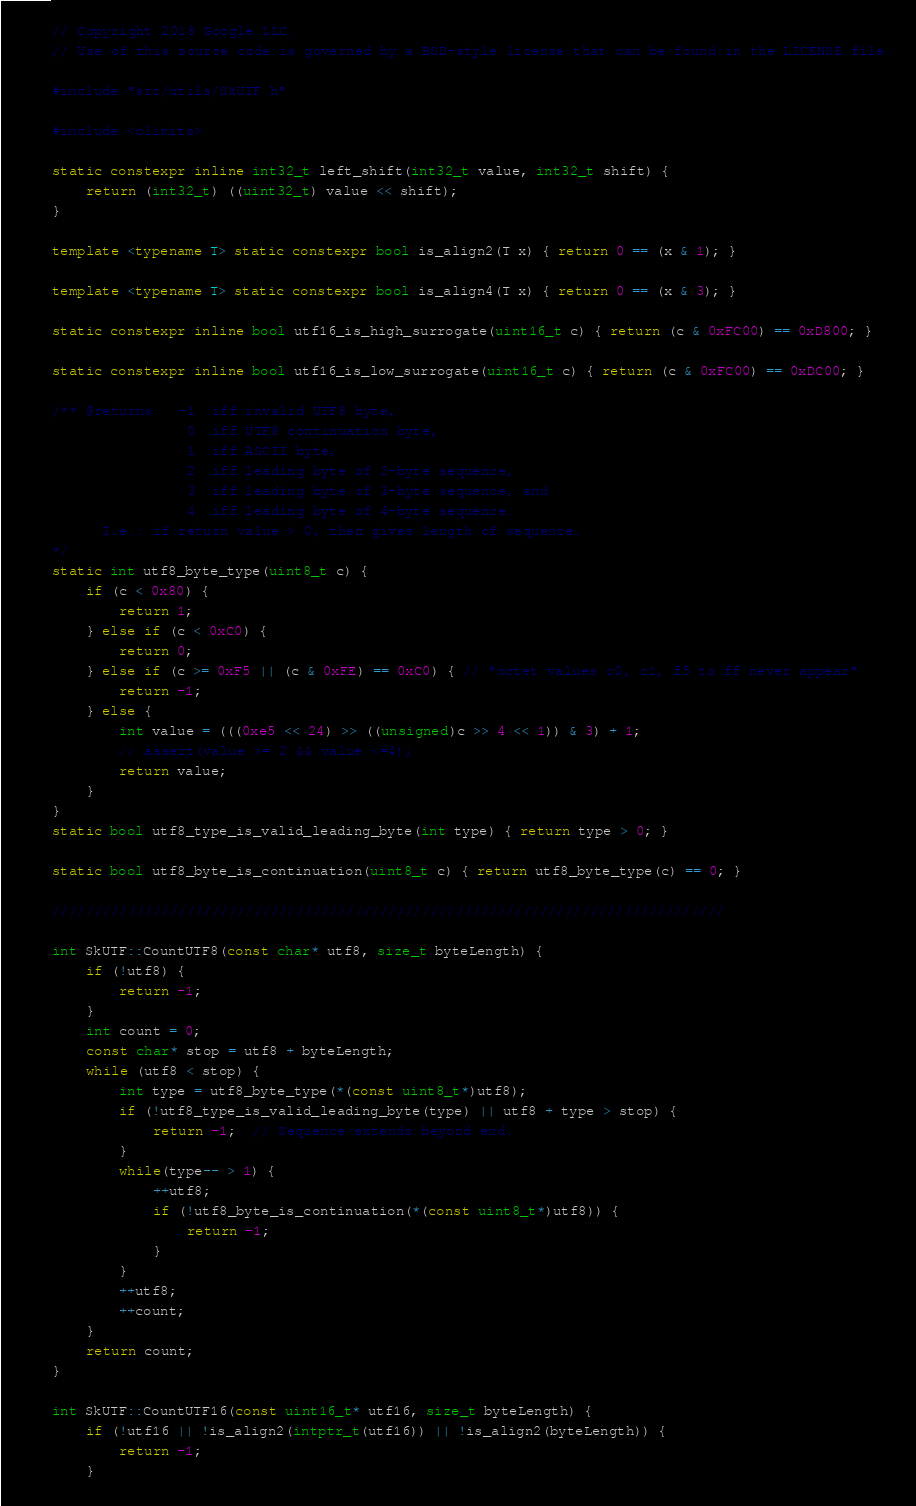<code> <loc_0><loc_0><loc_500><loc_500><_C++_>// Copyright 2018 Google LLC.
// Use of this source code is governed by a BSD-style license that can be found in the LICENSE file.

#include "src/utils/SkUTF.h"

#include <climits>

static constexpr inline int32_t left_shift(int32_t value, int32_t shift) {
    return (int32_t) ((uint32_t) value << shift);
}

template <typename T> static constexpr bool is_align2(T x) { return 0 == (x & 1); }

template <typename T> static constexpr bool is_align4(T x) { return 0 == (x & 3); }

static constexpr inline bool utf16_is_high_surrogate(uint16_t c) { return (c & 0xFC00) == 0xD800; }

static constexpr inline bool utf16_is_low_surrogate(uint16_t c) { return (c & 0xFC00) == 0xDC00; }

/** @returns   -1  iff invalid UTF8 byte,
                0  iff UTF8 continuation byte,
                1  iff ASCII byte,
                2  iff leading byte of 2-byte sequence,
                3  iff leading byte of 3-byte sequence, and
                4  iff leading byte of 4-byte sequence.
      I.e.: if return value > 0, then gives length of sequence.
*/
static int utf8_byte_type(uint8_t c) {
    if (c < 0x80) {
        return 1;
    } else if (c < 0xC0) {
        return 0;
    } else if (c >= 0xF5 || (c & 0xFE) == 0xC0) { // "octet values c0, c1, f5 to ff never appear"
        return -1;
    } else {
        int value = (((0xe5 << 24) >> ((unsigned)c >> 4 << 1)) & 3) + 1;
        // assert(value >= 2 && value <=4);
        return value;
    }
}
static bool utf8_type_is_valid_leading_byte(int type) { return type > 0; }

static bool utf8_byte_is_continuation(uint8_t c) { return utf8_byte_type(c) == 0; }

////////////////////////////////////////////////////////////////////////////////

int SkUTF::CountUTF8(const char* utf8, size_t byteLength) {
    if (!utf8) {
        return -1;
    }
    int count = 0;
    const char* stop = utf8 + byteLength;
    while (utf8 < stop) {
        int type = utf8_byte_type(*(const uint8_t*)utf8);
        if (!utf8_type_is_valid_leading_byte(type) || utf8 + type > stop) {
            return -1;  // Sequence extends beyond end.
        }
        while(type-- > 1) {
            ++utf8;
            if (!utf8_byte_is_continuation(*(const uint8_t*)utf8)) {
                return -1;
            }
        }
        ++utf8;
        ++count;
    }
    return count;
}

int SkUTF::CountUTF16(const uint16_t* utf16, size_t byteLength) {
    if (!utf16 || !is_align2(intptr_t(utf16)) || !is_align2(byteLength)) {
        return -1;
    }</code> 